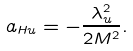<formula> <loc_0><loc_0><loc_500><loc_500>a _ { H u } = - \frac { \lambda _ { u } ^ { 2 } } { 2 M ^ { 2 } } .</formula> 